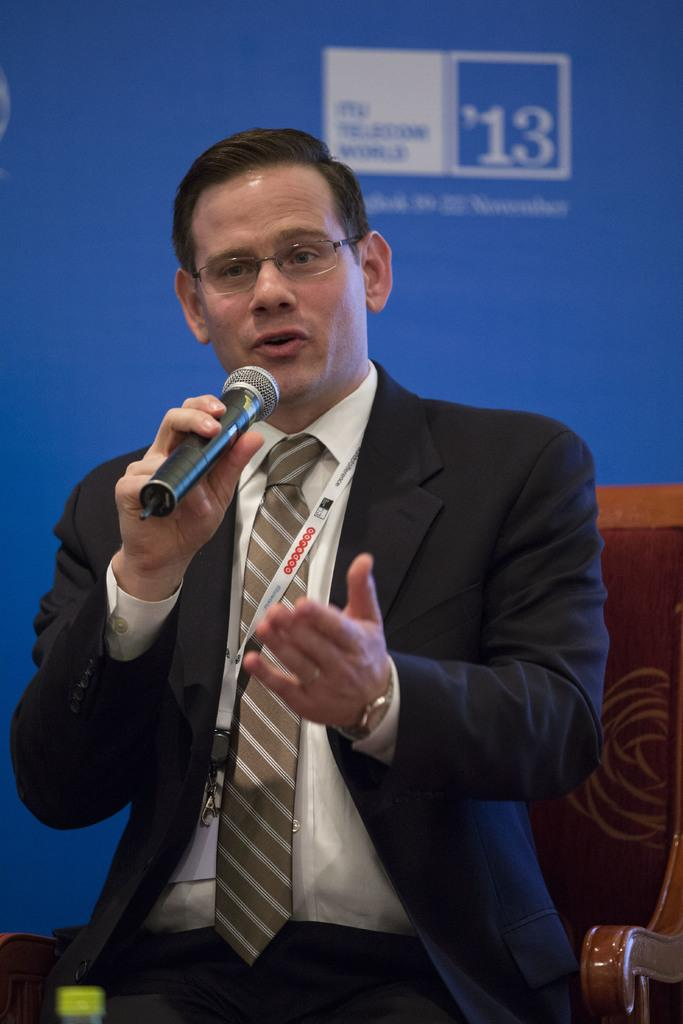Who is the main subject in the image? There is a man in the image. What is the man doing in the image? The man is sitting on a chair and talking on a microphone. What nerve is the man using to control his laughter while talking on the microphone? The image does not show the man laughing or using a specific nerve to control his laughter. 